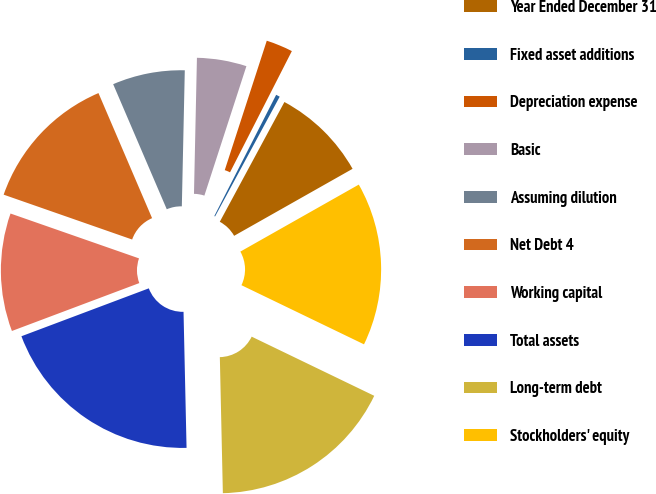<chart> <loc_0><loc_0><loc_500><loc_500><pie_chart><fcel>Year Ended December 31<fcel>Fixed asset additions<fcel>Depreciation expense<fcel>Basic<fcel>Assuming dilution<fcel>Net Debt 4<fcel>Working capital<fcel>Total assets<fcel>Long-term debt<fcel>Stockholders' equity<nl><fcel>8.93%<fcel>0.37%<fcel>2.51%<fcel>4.65%<fcel>6.79%<fcel>13.21%<fcel>11.07%<fcel>19.63%<fcel>17.49%<fcel>15.35%<nl></chart> 